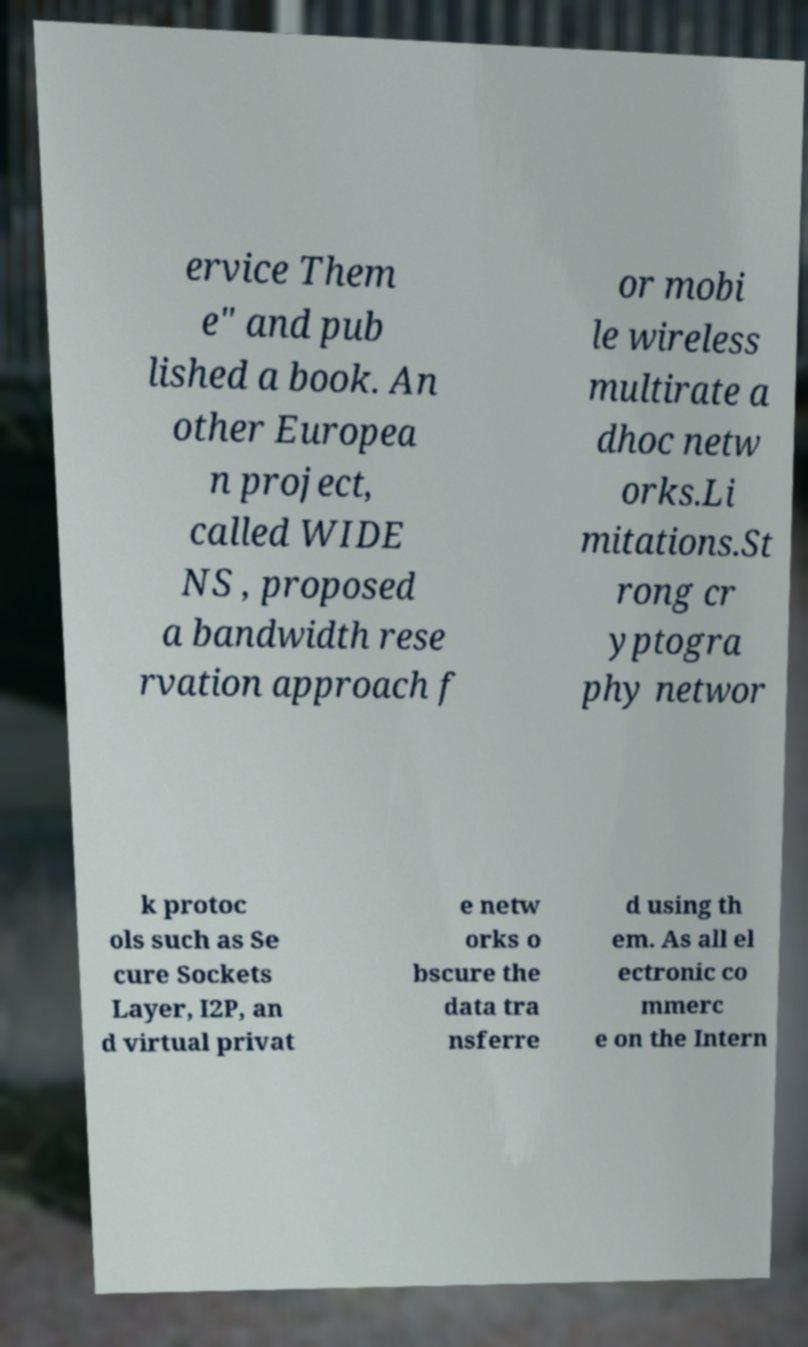There's text embedded in this image that I need extracted. Can you transcribe it verbatim? ervice Them e" and pub lished a book. An other Europea n project, called WIDE NS , proposed a bandwidth rese rvation approach f or mobi le wireless multirate a dhoc netw orks.Li mitations.St rong cr yptogra phy networ k protoc ols such as Se cure Sockets Layer, I2P, an d virtual privat e netw orks o bscure the data tra nsferre d using th em. As all el ectronic co mmerc e on the Intern 